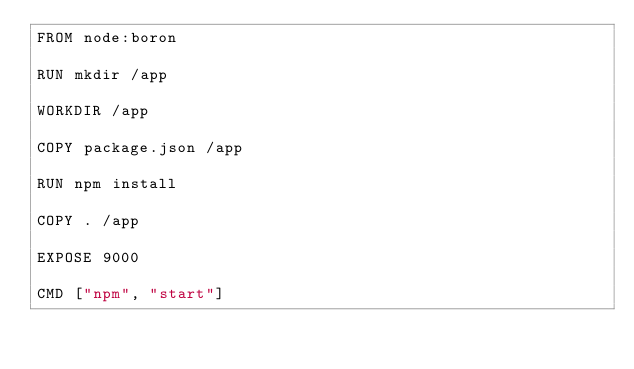Convert code to text. <code><loc_0><loc_0><loc_500><loc_500><_Dockerfile_>FROM node:boron

RUN mkdir /app

WORKDIR /app

COPY package.json /app

RUN npm install

COPY . /app

EXPOSE 9000

CMD ["npm", "start"]
</code> 